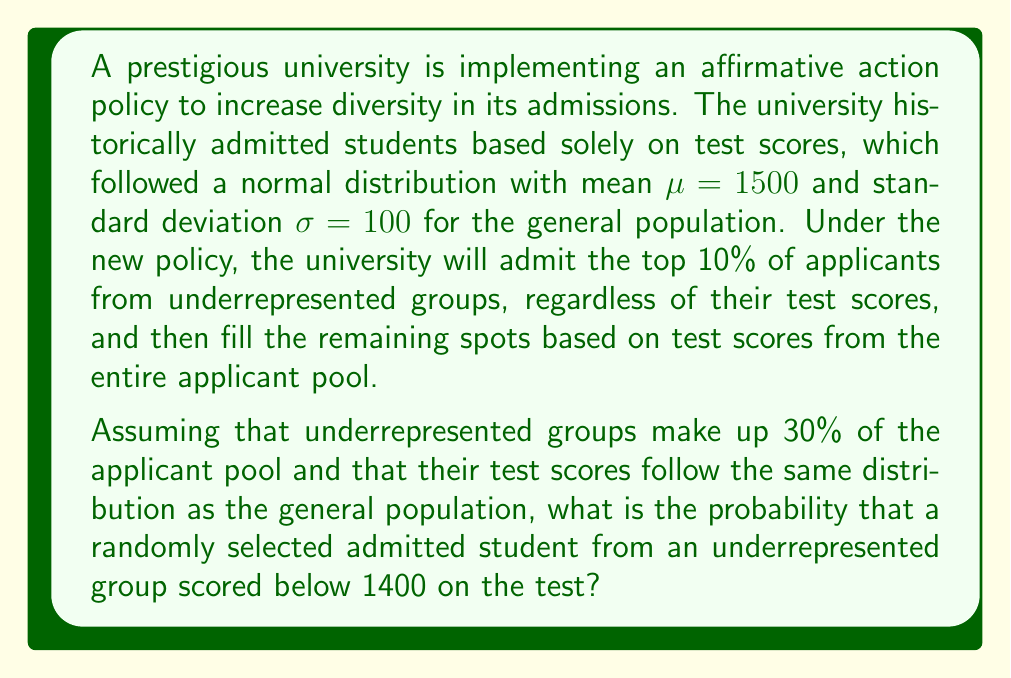Show me your answer to this math problem. To solve this problem, we need to consider two scenarios for admitted students from underrepresented groups:

1. Those admitted through the top 10% policy
2. Those admitted based on their test scores

Let's approach this step-by-step:

1. Calculate the probability of scoring below 1400 for the general population:
   $z = \frac{1400 - 1500}{100} = -1$
   $P(X < 1400) = \Phi(-1) \approx 0.1587$

2. For the top 10% policy:
   - All students in this group are admitted regardless of their score
   - The probability of scoring below 1400 in this group is the same as the general population: 0.1587

3. For those admitted based on test scores:
   - We need to find the cutoff score for the remaining spots
   - Let $x$ be the proportion of total spots filled by underrepresented groups
   - $x = 0.3 \cdot 0.1 + 0.3 \cdot (1-0.1) \cdot P(X > c)$, where $c$ is the cutoff score
   - The remaining $1-x$ proportion is filled by the general population
   - $(1-x) = 0.7 \cdot P(X > c)$
   - Solving these equations, we find $c \approx 1645$

4. For underrepresented students admitted based on scores:
   $P(1400 < X < 1645 | X > 1645) = \frac{P(1400 < X < 1645)}{P(X > 1645)}$
   $= \frac{\Phi(1.45) - \Phi(-1)}{1 - \Phi(1.45)} \approx 0.3421$

5. Combine the probabilities:
   $P(\text{below 1400}) = 0.1 \cdot 0.1587 + 0.9 \cdot 0 = 0.01587$

Therefore, the probability that a randomly selected admitted student from an underrepresented group scored below 1400 is approximately 0.01587 or 1.587%.
Answer: 0.01587 